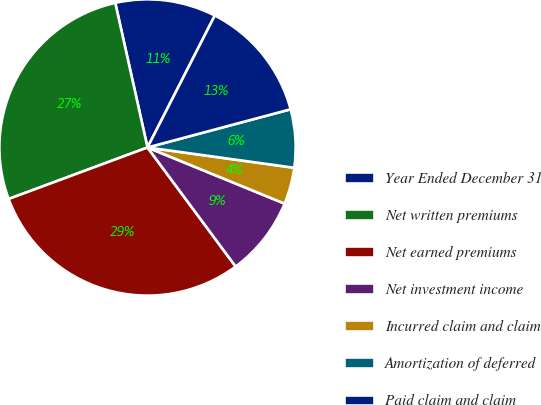<chart> <loc_0><loc_0><loc_500><loc_500><pie_chart><fcel>Year Ended December 31<fcel>Net written premiums<fcel>Net earned premiums<fcel>Net investment income<fcel>Incurred claim and claim<fcel>Amortization of deferred<fcel>Paid claim and claim<nl><fcel>11.0%<fcel>27.16%<fcel>29.49%<fcel>8.67%<fcel>4.0%<fcel>6.34%<fcel>13.34%<nl></chart> 